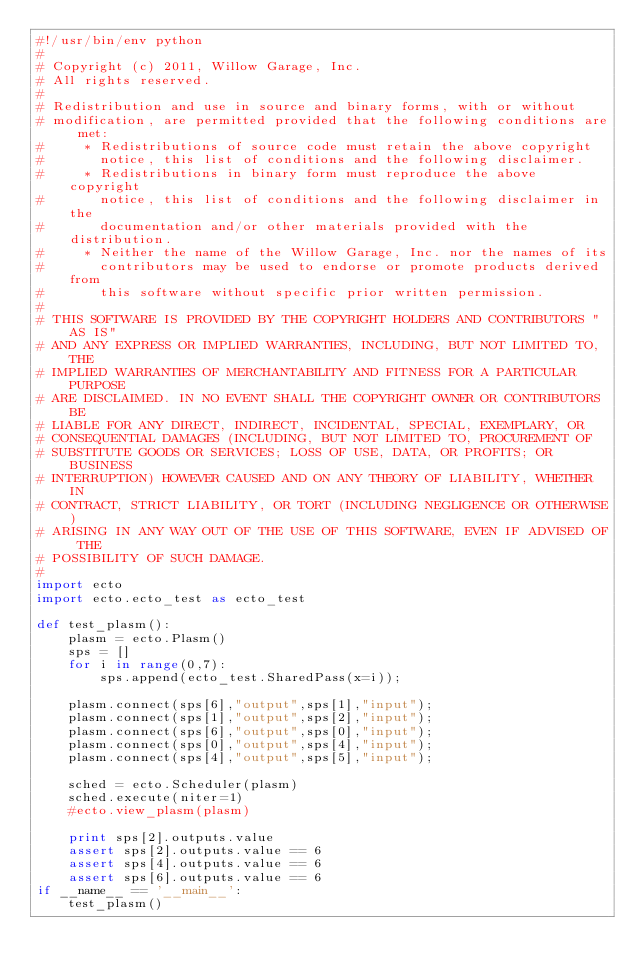<code> <loc_0><loc_0><loc_500><loc_500><_Python_>#!/usr/bin/env python
# 
# Copyright (c) 2011, Willow Garage, Inc.
# All rights reserved.
# 
# Redistribution and use in source and binary forms, with or without
# modification, are permitted provided that the following conditions are met:
#     * Redistributions of source code must retain the above copyright
#       notice, this list of conditions and the following disclaimer.
#     * Redistributions in binary form must reproduce the above copyright
#       notice, this list of conditions and the following disclaimer in the
#       documentation and/or other materials provided with the distribution.
#     * Neither the name of the Willow Garage, Inc. nor the names of its
#       contributors may be used to endorse or promote products derived from
#       this software without specific prior written permission.
# 
# THIS SOFTWARE IS PROVIDED BY THE COPYRIGHT HOLDERS AND CONTRIBUTORS "AS IS"
# AND ANY EXPRESS OR IMPLIED WARRANTIES, INCLUDING, BUT NOT LIMITED TO, THE
# IMPLIED WARRANTIES OF MERCHANTABILITY AND FITNESS FOR A PARTICULAR PURPOSE
# ARE DISCLAIMED. IN NO EVENT SHALL THE COPYRIGHT OWNER OR CONTRIBUTORS BE
# LIABLE FOR ANY DIRECT, INDIRECT, INCIDENTAL, SPECIAL, EXEMPLARY, OR
# CONSEQUENTIAL DAMAGES (INCLUDING, BUT NOT LIMITED TO, PROCUREMENT OF
# SUBSTITUTE GOODS OR SERVICES; LOSS OF USE, DATA, OR PROFITS; OR BUSINESS
# INTERRUPTION) HOWEVER CAUSED AND ON ANY THEORY OF LIABILITY, WHETHER IN
# CONTRACT, STRICT LIABILITY, OR TORT (INCLUDING NEGLIGENCE OR OTHERWISE)
# ARISING IN ANY WAY OUT OF THE USE OF THIS SOFTWARE, EVEN IF ADVISED OF THE
# POSSIBILITY OF SUCH DAMAGE.
# 
import ecto
import ecto.ecto_test as ecto_test

def test_plasm():
    plasm = ecto.Plasm()
    sps = []
    for i in range(0,7):
        sps.append(ecto_test.SharedPass(x=i));
        
    plasm.connect(sps[6],"output",sps[1],"input");
    plasm.connect(sps[1],"output",sps[2],"input");
    plasm.connect(sps[6],"output",sps[0],"input");
    plasm.connect(sps[0],"output",sps[4],"input");
    plasm.connect(sps[4],"output",sps[5],"input");

    sched = ecto.Scheduler(plasm)
    sched.execute(niter=1)
    #ecto.view_plasm(plasm)

    print sps[2].outputs.value
    assert sps[2].outputs.value == 6
    assert sps[4].outputs.value == 6
    assert sps[6].outputs.value == 6
if __name__ == '__main__':
    test_plasm()




</code> 